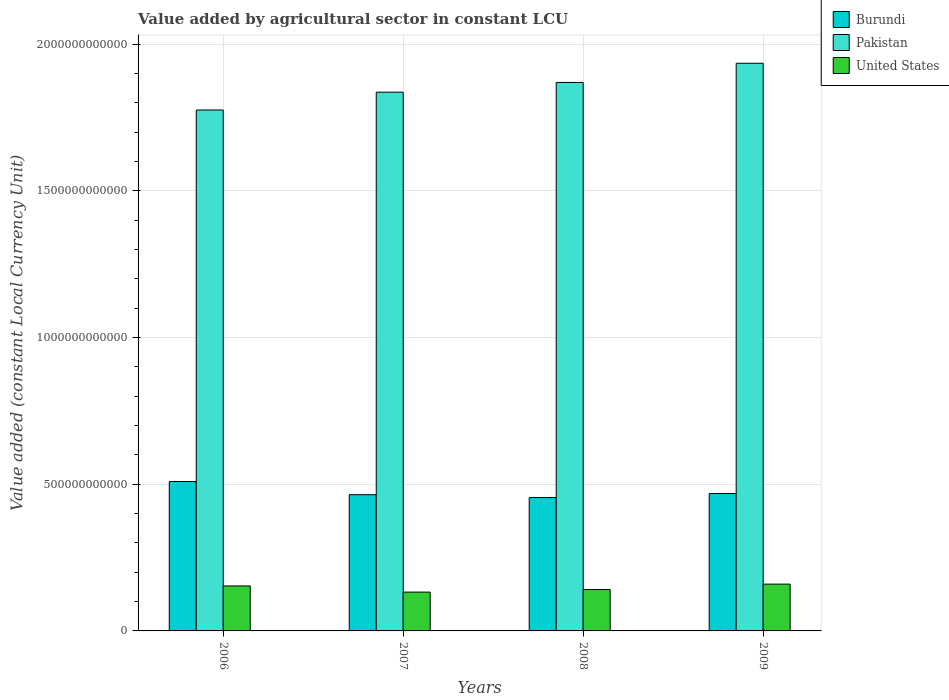How many groups of bars are there?
Give a very brief answer. 4. Are the number of bars per tick equal to the number of legend labels?
Keep it short and to the point. Yes. Are the number of bars on each tick of the X-axis equal?
Make the answer very short. Yes. How many bars are there on the 4th tick from the left?
Your answer should be compact. 3. What is the value added by agricultural sector in United States in 2006?
Make the answer very short. 1.53e+11. Across all years, what is the maximum value added by agricultural sector in United States?
Give a very brief answer. 1.60e+11. Across all years, what is the minimum value added by agricultural sector in Pakistan?
Offer a very short reply. 1.78e+12. In which year was the value added by agricultural sector in United States maximum?
Keep it short and to the point. 2009. What is the total value added by agricultural sector in Pakistan in the graph?
Your response must be concise. 7.42e+12. What is the difference between the value added by agricultural sector in Burundi in 2008 and that in 2009?
Ensure brevity in your answer.  -1.37e+1. What is the difference between the value added by agricultural sector in Pakistan in 2008 and the value added by agricultural sector in Burundi in 2009?
Provide a succinct answer. 1.40e+12. What is the average value added by agricultural sector in Burundi per year?
Provide a succinct answer. 4.74e+11. In the year 2009, what is the difference between the value added by agricultural sector in United States and value added by agricultural sector in Pakistan?
Ensure brevity in your answer.  -1.78e+12. What is the ratio of the value added by agricultural sector in United States in 2006 to that in 2007?
Ensure brevity in your answer.  1.16. Is the value added by agricultural sector in United States in 2007 less than that in 2009?
Keep it short and to the point. Yes. What is the difference between the highest and the second highest value added by agricultural sector in Pakistan?
Your response must be concise. 6.54e+1. What is the difference between the highest and the lowest value added by agricultural sector in United States?
Give a very brief answer. 2.72e+1. In how many years, is the value added by agricultural sector in Burundi greater than the average value added by agricultural sector in Burundi taken over all years?
Offer a very short reply. 1. What does the 2nd bar from the left in 2007 represents?
Give a very brief answer. Pakistan. Are all the bars in the graph horizontal?
Ensure brevity in your answer.  No. How many years are there in the graph?
Provide a succinct answer. 4. What is the difference between two consecutive major ticks on the Y-axis?
Your response must be concise. 5.00e+11. Are the values on the major ticks of Y-axis written in scientific E-notation?
Ensure brevity in your answer.  No. Does the graph contain any zero values?
Ensure brevity in your answer.  No. How are the legend labels stacked?
Your answer should be compact. Vertical. What is the title of the graph?
Ensure brevity in your answer.  Value added by agricultural sector in constant LCU. Does "Barbados" appear as one of the legend labels in the graph?
Make the answer very short. No. What is the label or title of the Y-axis?
Offer a very short reply. Value added (constant Local Currency Unit). What is the Value added (constant Local Currency Unit) of Burundi in 2006?
Provide a succinct answer. 5.09e+11. What is the Value added (constant Local Currency Unit) in Pakistan in 2006?
Keep it short and to the point. 1.78e+12. What is the Value added (constant Local Currency Unit) in United States in 2006?
Ensure brevity in your answer.  1.53e+11. What is the Value added (constant Local Currency Unit) of Burundi in 2007?
Provide a succinct answer. 4.64e+11. What is the Value added (constant Local Currency Unit) of Pakistan in 2007?
Provide a short and direct response. 1.84e+12. What is the Value added (constant Local Currency Unit) in United States in 2007?
Your answer should be compact. 1.32e+11. What is the Value added (constant Local Currency Unit) in Burundi in 2008?
Offer a terse response. 4.55e+11. What is the Value added (constant Local Currency Unit) of Pakistan in 2008?
Provide a succinct answer. 1.87e+12. What is the Value added (constant Local Currency Unit) in United States in 2008?
Offer a terse response. 1.41e+11. What is the Value added (constant Local Currency Unit) of Burundi in 2009?
Offer a very short reply. 4.68e+11. What is the Value added (constant Local Currency Unit) of Pakistan in 2009?
Provide a succinct answer. 1.93e+12. What is the Value added (constant Local Currency Unit) of United States in 2009?
Your answer should be very brief. 1.60e+11. Across all years, what is the maximum Value added (constant Local Currency Unit) in Burundi?
Offer a terse response. 5.09e+11. Across all years, what is the maximum Value added (constant Local Currency Unit) of Pakistan?
Provide a short and direct response. 1.93e+12. Across all years, what is the maximum Value added (constant Local Currency Unit) of United States?
Provide a succinct answer. 1.60e+11. Across all years, what is the minimum Value added (constant Local Currency Unit) of Burundi?
Your answer should be very brief. 4.55e+11. Across all years, what is the minimum Value added (constant Local Currency Unit) of Pakistan?
Provide a succinct answer. 1.78e+12. Across all years, what is the minimum Value added (constant Local Currency Unit) in United States?
Your answer should be compact. 1.32e+11. What is the total Value added (constant Local Currency Unit) of Burundi in the graph?
Offer a very short reply. 1.90e+12. What is the total Value added (constant Local Currency Unit) in Pakistan in the graph?
Your response must be concise. 7.42e+12. What is the total Value added (constant Local Currency Unit) in United States in the graph?
Provide a short and direct response. 5.86e+11. What is the difference between the Value added (constant Local Currency Unit) in Burundi in 2006 and that in 2007?
Ensure brevity in your answer.  4.49e+1. What is the difference between the Value added (constant Local Currency Unit) in Pakistan in 2006 and that in 2007?
Provide a succinct answer. -6.08e+1. What is the difference between the Value added (constant Local Currency Unit) in United States in 2006 and that in 2007?
Give a very brief answer. 2.10e+1. What is the difference between the Value added (constant Local Currency Unit) in Burundi in 2006 and that in 2008?
Offer a very short reply. 5.46e+1. What is the difference between the Value added (constant Local Currency Unit) in Pakistan in 2006 and that in 2008?
Ensure brevity in your answer.  -9.40e+1. What is the difference between the Value added (constant Local Currency Unit) of United States in 2006 and that in 2008?
Ensure brevity in your answer.  1.20e+1. What is the difference between the Value added (constant Local Currency Unit) in Burundi in 2006 and that in 2009?
Ensure brevity in your answer.  4.09e+1. What is the difference between the Value added (constant Local Currency Unit) in Pakistan in 2006 and that in 2009?
Provide a succinct answer. -1.59e+11. What is the difference between the Value added (constant Local Currency Unit) in United States in 2006 and that in 2009?
Ensure brevity in your answer.  -6.20e+09. What is the difference between the Value added (constant Local Currency Unit) in Burundi in 2007 and that in 2008?
Keep it short and to the point. 9.76e+09. What is the difference between the Value added (constant Local Currency Unit) of Pakistan in 2007 and that in 2008?
Give a very brief answer. -3.32e+1. What is the difference between the Value added (constant Local Currency Unit) of United States in 2007 and that in 2008?
Provide a short and direct response. -8.98e+09. What is the difference between the Value added (constant Local Currency Unit) of Burundi in 2007 and that in 2009?
Your answer should be very brief. -3.93e+09. What is the difference between the Value added (constant Local Currency Unit) in Pakistan in 2007 and that in 2009?
Your response must be concise. -9.86e+1. What is the difference between the Value added (constant Local Currency Unit) of United States in 2007 and that in 2009?
Your answer should be very brief. -2.72e+1. What is the difference between the Value added (constant Local Currency Unit) of Burundi in 2008 and that in 2009?
Provide a short and direct response. -1.37e+1. What is the difference between the Value added (constant Local Currency Unit) of Pakistan in 2008 and that in 2009?
Your answer should be very brief. -6.54e+1. What is the difference between the Value added (constant Local Currency Unit) of United States in 2008 and that in 2009?
Keep it short and to the point. -1.82e+1. What is the difference between the Value added (constant Local Currency Unit) of Burundi in 2006 and the Value added (constant Local Currency Unit) of Pakistan in 2007?
Ensure brevity in your answer.  -1.33e+12. What is the difference between the Value added (constant Local Currency Unit) of Burundi in 2006 and the Value added (constant Local Currency Unit) of United States in 2007?
Give a very brief answer. 3.77e+11. What is the difference between the Value added (constant Local Currency Unit) of Pakistan in 2006 and the Value added (constant Local Currency Unit) of United States in 2007?
Provide a short and direct response. 1.64e+12. What is the difference between the Value added (constant Local Currency Unit) in Burundi in 2006 and the Value added (constant Local Currency Unit) in Pakistan in 2008?
Your answer should be compact. -1.36e+12. What is the difference between the Value added (constant Local Currency Unit) in Burundi in 2006 and the Value added (constant Local Currency Unit) in United States in 2008?
Your answer should be compact. 3.68e+11. What is the difference between the Value added (constant Local Currency Unit) of Pakistan in 2006 and the Value added (constant Local Currency Unit) of United States in 2008?
Your response must be concise. 1.63e+12. What is the difference between the Value added (constant Local Currency Unit) of Burundi in 2006 and the Value added (constant Local Currency Unit) of Pakistan in 2009?
Keep it short and to the point. -1.43e+12. What is the difference between the Value added (constant Local Currency Unit) in Burundi in 2006 and the Value added (constant Local Currency Unit) in United States in 2009?
Provide a succinct answer. 3.50e+11. What is the difference between the Value added (constant Local Currency Unit) in Pakistan in 2006 and the Value added (constant Local Currency Unit) in United States in 2009?
Give a very brief answer. 1.62e+12. What is the difference between the Value added (constant Local Currency Unit) of Burundi in 2007 and the Value added (constant Local Currency Unit) of Pakistan in 2008?
Your answer should be compact. -1.41e+12. What is the difference between the Value added (constant Local Currency Unit) in Burundi in 2007 and the Value added (constant Local Currency Unit) in United States in 2008?
Your answer should be very brief. 3.23e+11. What is the difference between the Value added (constant Local Currency Unit) in Pakistan in 2007 and the Value added (constant Local Currency Unit) in United States in 2008?
Ensure brevity in your answer.  1.69e+12. What is the difference between the Value added (constant Local Currency Unit) of Burundi in 2007 and the Value added (constant Local Currency Unit) of Pakistan in 2009?
Provide a succinct answer. -1.47e+12. What is the difference between the Value added (constant Local Currency Unit) in Burundi in 2007 and the Value added (constant Local Currency Unit) in United States in 2009?
Provide a short and direct response. 3.05e+11. What is the difference between the Value added (constant Local Currency Unit) in Pakistan in 2007 and the Value added (constant Local Currency Unit) in United States in 2009?
Give a very brief answer. 1.68e+12. What is the difference between the Value added (constant Local Currency Unit) in Burundi in 2008 and the Value added (constant Local Currency Unit) in Pakistan in 2009?
Offer a very short reply. -1.48e+12. What is the difference between the Value added (constant Local Currency Unit) of Burundi in 2008 and the Value added (constant Local Currency Unit) of United States in 2009?
Ensure brevity in your answer.  2.95e+11. What is the difference between the Value added (constant Local Currency Unit) in Pakistan in 2008 and the Value added (constant Local Currency Unit) in United States in 2009?
Make the answer very short. 1.71e+12. What is the average Value added (constant Local Currency Unit) of Burundi per year?
Keep it short and to the point. 4.74e+11. What is the average Value added (constant Local Currency Unit) of Pakistan per year?
Your answer should be very brief. 1.85e+12. What is the average Value added (constant Local Currency Unit) in United States per year?
Give a very brief answer. 1.47e+11. In the year 2006, what is the difference between the Value added (constant Local Currency Unit) in Burundi and Value added (constant Local Currency Unit) in Pakistan?
Offer a very short reply. -1.27e+12. In the year 2006, what is the difference between the Value added (constant Local Currency Unit) of Burundi and Value added (constant Local Currency Unit) of United States?
Provide a succinct answer. 3.56e+11. In the year 2006, what is the difference between the Value added (constant Local Currency Unit) in Pakistan and Value added (constant Local Currency Unit) in United States?
Offer a terse response. 1.62e+12. In the year 2007, what is the difference between the Value added (constant Local Currency Unit) of Burundi and Value added (constant Local Currency Unit) of Pakistan?
Offer a very short reply. -1.37e+12. In the year 2007, what is the difference between the Value added (constant Local Currency Unit) in Burundi and Value added (constant Local Currency Unit) in United States?
Make the answer very short. 3.32e+11. In the year 2007, what is the difference between the Value added (constant Local Currency Unit) in Pakistan and Value added (constant Local Currency Unit) in United States?
Offer a terse response. 1.70e+12. In the year 2008, what is the difference between the Value added (constant Local Currency Unit) in Burundi and Value added (constant Local Currency Unit) in Pakistan?
Make the answer very short. -1.41e+12. In the year 2008, what is the difference between the Value added (constant Local Currency Unit) of Burundi and Value added (constant Local Currency Unit) of United States?
Give a very brief answer. 3.13e+11. In the year 2008, what is the difference between the Value added (constant Local Currency Unit) in Pakistan and Value added (constant Local Currency Unit) in United States?
Your answer should be very brief. 1.73e+12. In the year 2009, what is the difference between the Value added (constant Local Currency Unit) in Burundi and Value added (constant Local Currency Unit) in Pakistan?
Offer a terse response. -1.47e+12. In the year 2009, what is the difference between the Value added (constant Local Currency Unit) of Burundi and Value added (constant Local Currency Unit) of United States?
Your answer should be compact. 3.09e+11. In the year 2009, what is the difference between the Value added (constant Local Currency Unit) in Pakistan and Value added (constant Local Currency Unit) in United States?
Keep it short and to the point. 1.78e+12. What is the ratio of the Value added (constant Local Currency Unit) in Burundi in 2006 to that in 2007?
Provide a short and direct response. 1.1. What is the ratio of the Value added (constant Local Currency Unit) in Pakistan in 2006 to that in 2007?
Your answer should be very brief. 0.97. What is the ratio of the Value added (constant Local Currency Unit) of United States in 2006 to that in 2007?
Your response must be concise. 1.16. What is the ratio of the Value added (constant Local Currency Unit) in Burundi in 2006 to that in 2008?
Give a very brief answer. 1.12. What is the ratio of the Value added (constant Local Currency Unit) of Pakistan in 2006 to that in 2008?
Keep it short and to the point. 0.95. What is the ratio of the Value added (constant Local Currency Unit) of United States in 2006 to that in 2008?
Offer a terse response. 1.09. What is the ratio of the Value added (constant Local Currency Unit) of Burundi in 2006 to that in 2009?
Give a very brief answer. 1.09. What is the ratio of the Value added (constant Local Currency Unit) of Pakistan in 2006 to that in 2009?
Ensure brevity in your answer.  0.92. What is the ratio of the Value added (constant Local Currency Unit) of United States in 2006 to that in 2009?
Make the answer very short. 0.96. What is the ratio of the Value added (constant Local Currency Unit) in Burundi in 2007 to that in 2008?
Provide a short and direct response. 1.02. What is the ratio of the Value added (constant Local Currency Unit) of Pakistan in 2007 to that in 2008?
Your response must be concise. 0.98. What is the ratio of the Value added (constant Local Currency Unit) in United States in 2007 to that in 2008?
Your answer should be very brief. 0.94. What is the ratio of the Value added (constant Local Currency Unit) in Burundi in 2007 to that in 2009?
Give a very brief answer. 0.99. What is the ratio of the Value added (constant Local Currency Unit) of Pakistan in 2007 to that in 2009?
Your answer should be compact. 0.95. What is the ratio of the Value added (constant Local Currency Unit) of United States in 2007 to that in 2009?
Make the answer very short. 0.83. What is the ratio of the Value added (constant Local Currency Unit) in Burundi in 2008 to that in 2009?
Provide a succinct answer. 0.97. What is the ratio of the Value added (constant Local Currency Unit) of Pakistan in 2008 to that in 2009?
Your answer should be very brief. 0.97. What is the ratio of the Value added (constant Local Currency Unit) of United States in 2008 to that in 2009?
Your answer should be very brief. 0.89. What is the difference between the highest and the second highest Value added (constant Local Currency Unit) in Burundi?
Give a very brief answer. 4.09e+1. What is the difference between the highest and the second highest Value added (constant Local Currency Unit) of Pakistan?
Your answer should be compact. 6.54e+1. What is the difference between the highest and the second highest Value added (constant Local Currency Unit) in United States?
Provide a succinct answer. 6.20e+09. What is the difference between the highest and the lowest Value added (constant Local Currency Unit) of Burundi?
Provide a succinct answer. 5.46e+1. What is the difference between the highest and the lowest Value added (constant Local Currency Unit) in Pakistan?
Your answer should be very brief. 1.59e+11. What is the difference between the highest and the lowest Value added (constant Local Currency Unit) of United States?
Make the answer very short. 2.72e+1. 